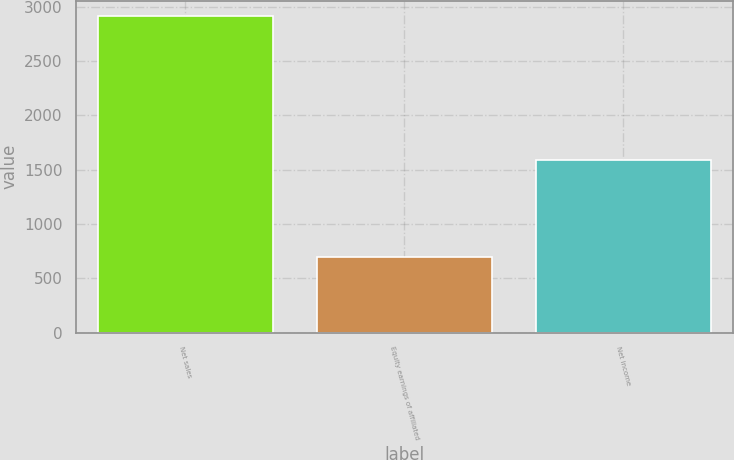Convert chart. <chart><loc_0><loc_0><loc_500><loc_500><bar_chart><fcel>Net sales<fcel>Equity earnings of affiliated<fcel>Net income<nl><fcel>2909<fcel>692<fcel>1589<nl></chart> 